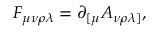<formula> <loc_0><loc_0><loc_500><loc_500>F _ { \mu \nu \rho \lambda } = \partial _ { [ \mu } A _ { \nu \rho \lambda ] } ,</formula> 